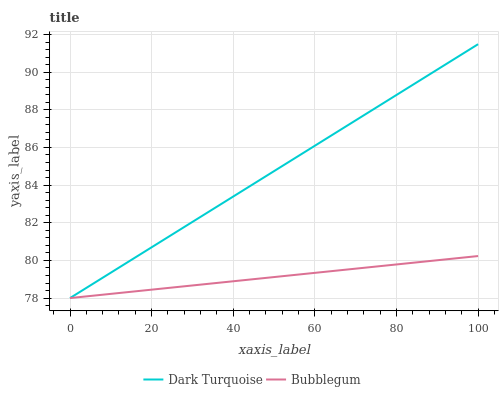Does Bubblegum have the minimum area under the curve?
Answer yes or no. Yes. Does Dark Turquoise have the maximum area under the curve?
Answer yes or no. Yes. Does Bubblegum have the maximum area under the curve?
Answer yes or no. No. Is Bubblegum the smoothest?
Answer yes or no. Yes. Is Dark Turquoise the roughest?
Answer yes or no. Yes. Is Bubblegum the roughest?
Answer yes or no. No. Does Dark Turquoise have the lowest value?
Answer yes or no. Yes. Does Dark Turquoise have the highest value?
Answer yes or no. Yes. Does Bubblegum have the highest value?
Answer yes or no. No. Does Bubblegum intersect Dark Turquoise?
Answer yes or no. Yes. Is Bubblegum less than Dark Turquoise?
Answer yes or no. No. Is Bubblegum greater than Dark Turquoise?
Answer yes or no. No. 